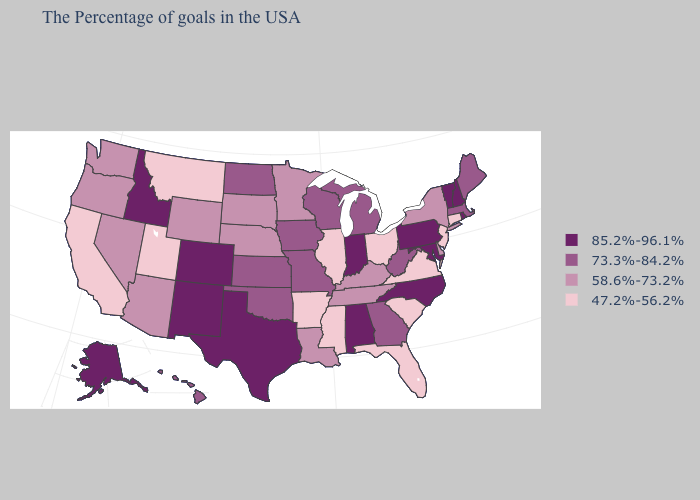Does Montana have the lowest value in the USA?
Be succinct. Yes. Does the map have missing data?
Quick response, please. No. What is the value of Michigan?
Keep it brief. 73.3%-84.2%. Which states hav the highest value in the South?
Short answer required. Maryland, North Carolina, Alabama, Texas. What is the highest value in states that border Delaware?
Keep it brief. 85.2%-96.1%. What is the value of Washington?
Quick response, please. 58.6%-73.2%. What is the lowest value in the USA?
Keep it brief. 47.2%-56.2%. What is the lowest value in the South?
Give a very brief answer. 47.2%-56.2%. Does Texas have a lower value than Virginia?
Short answer required. No. Is the legend a continuous bar?
Give a very brief answer. No. Does the first symbol in the legend represent the smallest category?
Quick response, please. No. Does South Dakota have a lower value than Missouri?
Keep it brief. Yes. Does Hawaii have the highest value in the West?
Be succinct. No. Name the states that have a value in the range 73.3%-84.2%?
Be succinct. Maine, Massachusetts, West Virginia, Georgia, Michigan, Wisconsin, Missouri, Iowa, Kansas, Oklahoma, North Dakota, Hawaii. What is the value of Louisiana?
Short answer required. 58.6%-73.2%. 